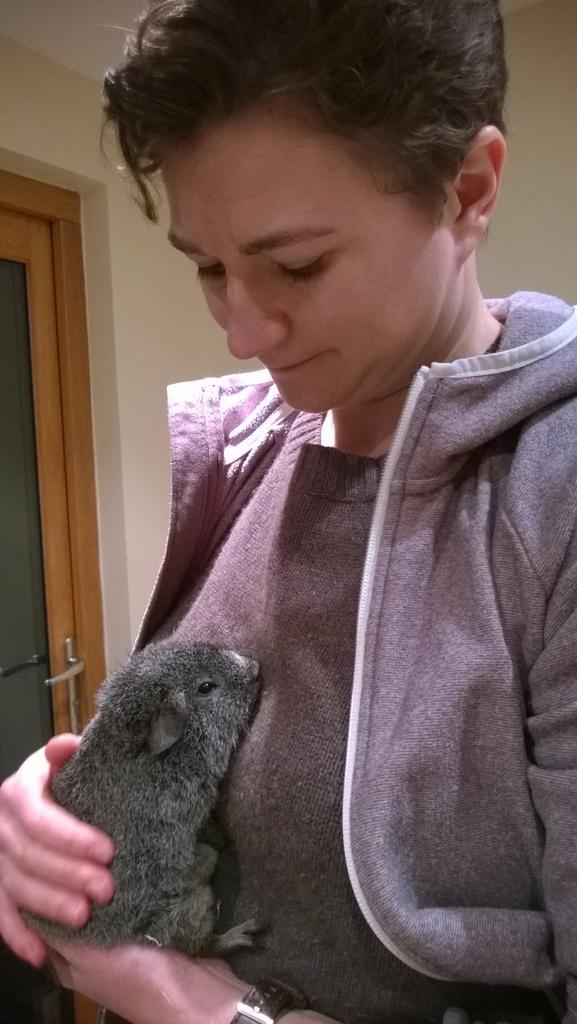Can you describe this image briefly? In this picture we can see a person is holding an animal. Behind the person, there is a wall and a door. 